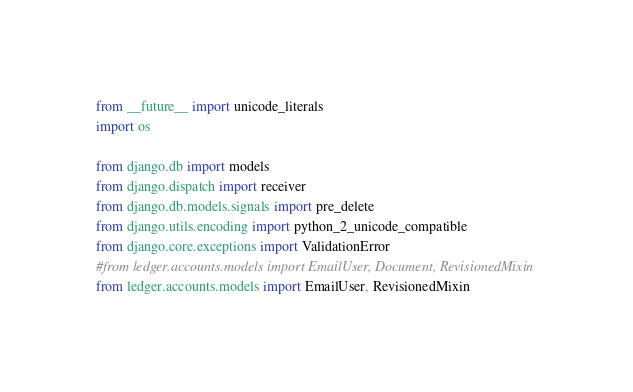<code> <loc_0><loc_0><loc_500><loc_500><_Python_>from __future__ import unicode_literals
import os

from django.db import models
from django.dispatch import receiver
from django.db.models.signals import pre_delete
from django.utils.encoding import python_2_unicode_compatible
from django.core.exceptions import ValidationError
#from ledger.accounts.models import EmailUser, Document, RevisionedMixin
from ledger.accounts.models import EmailUser, RevisionedMixin</code> 